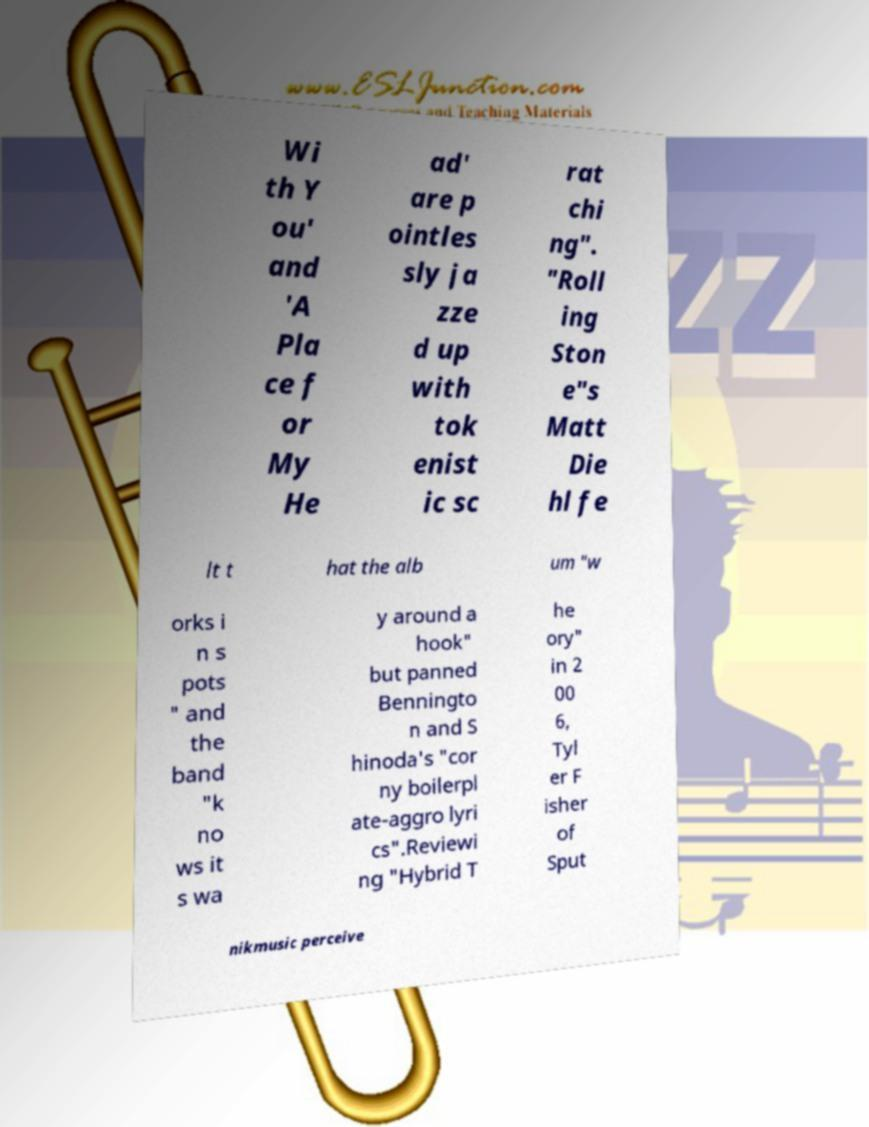Please read and relay the text visible in this image. What does it say? Wi th Y ou' and 'A Pla ce f or My He ad' are p ointles sly ja zze d up with tok enist ic sc rat chi ng". "Roll ing Ston e"s Matt Die hl fe lt t hat the alb um "w orks i n s pots " and the band "k no ws it s wa y around a hook" but panned Benningto n and S hinoda's "cor ny boilerpl ate-aggro lyri cs".Reviewi ng "Hybrid T he ory" in 2 00 6, Tyl er F isher of Sput nikmusic perceive 